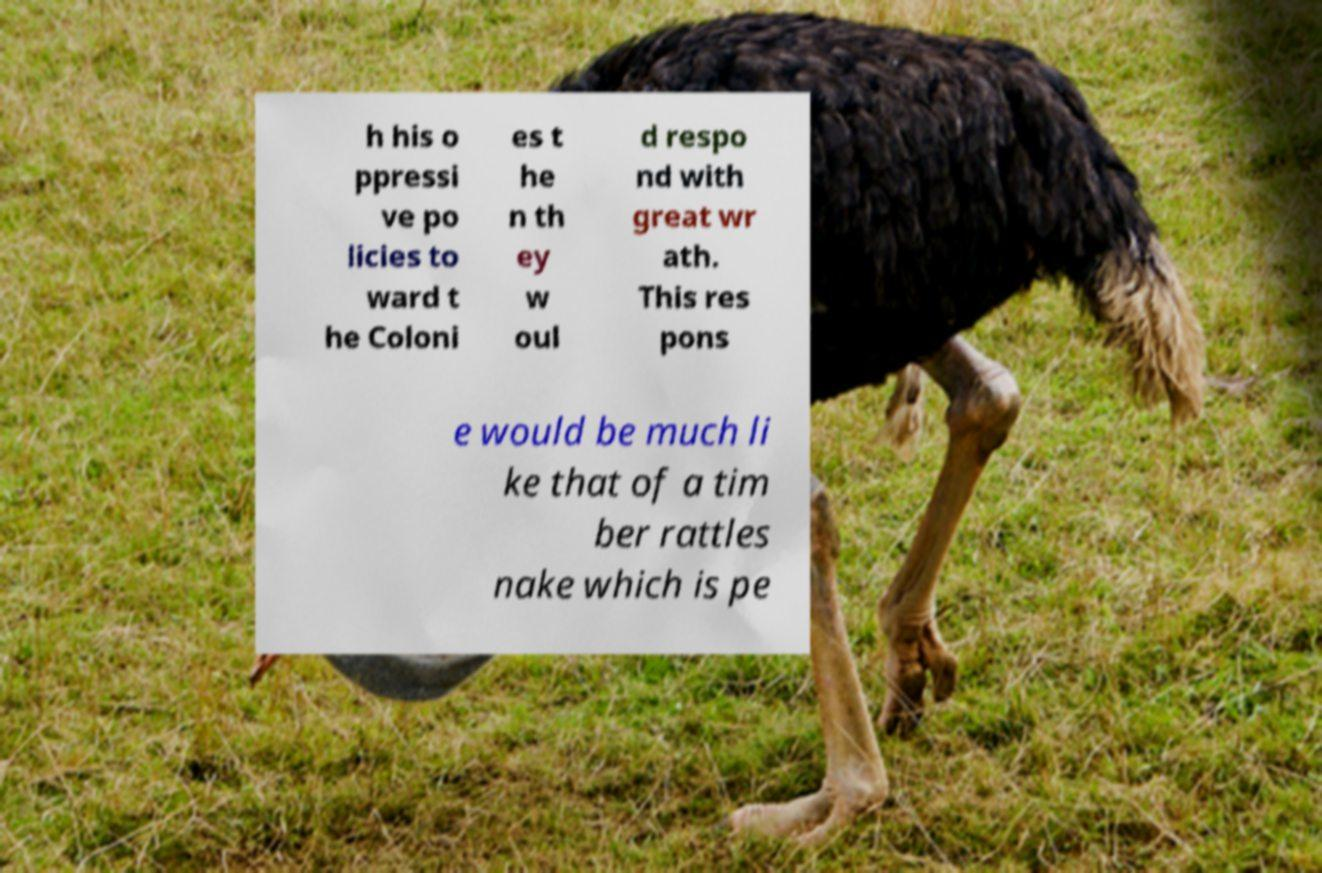Please identify and transcribe the text found in this image. h his o ppressi ve po licies to ward t he Coloni es t he n th ey w oul d respo nd with great wr ath. This res pons e would be much li ke that of a tim ber rattles nake which is pe 